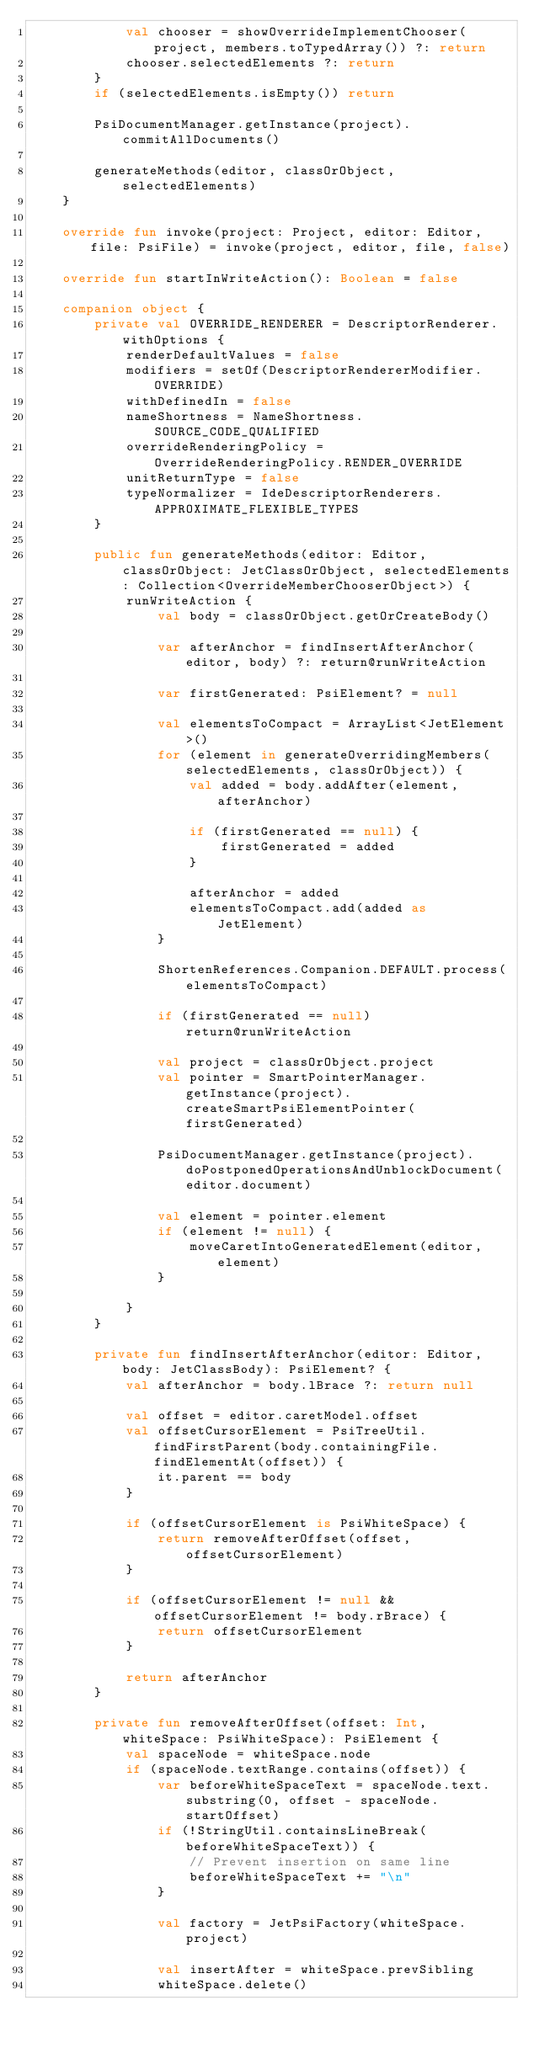<code> <loc_0><loc_0><loc_500><loc_500><_Kotlin_>            val chooser = showOverrideImplementChooser(project, members.toTypedArray()) ?: return
            chooser.selectedElements ?: return
        }
        if (selectedElements.isEmpty()) return

        PsiDocumentManager.getInstance(project).commitAllDocuments()

        generateMethods(editor, classOrObject, selectedElements)
    }

    override fun invoke(project: Project, editor: Editor, file: PsiFile) = invoke(project, editor, file, false)

    override fun startInWriteAction(): Boolean = false

    companion object {
        private val OVERRIDE_RENDERER = DescriptorRenderer.withOptions {
            renderDefaultValues = false
            modifiers = setOf(DescriptorRendererModifier.OVERRIDE)
            withDefinedIn = false
            nameShortness = NameShortness.SOURCE_CODE_QUALIFIED
            overrideRenderingPolicy = OverrideRenderingPolicy.RENDER_OVERRIDE
            unitReturnType = false
            typeNormalizer = IdeDescriptorRenderers.APPROXIMATE_FLEXIBLE_TYPES
        }

        public fun generateMethods(editor: Editor, classOrObject: JetClassOrObject, selectedElements: Collection<OverrideMemberChooserObject>) {
            runWriteAction {
                val body = classOrObject.getOrCreateBody()

                var afterAnchor = findInsertAfterAnchor(editor, body) ?: return@runWriteAction

                var firstGenerated: PsiElement? = null

                val elementsToCompact = ArrayList<JetElement>()
                for (element in generateOverridingMembers(selectedElements, classOrObject)) {
                    val added = body.addAfter(element, afterAnchor)

                    if (firstGenerated == null) {
                        firstGenerated = added
                    }

                    afterAnchor = added
                    elementsToCompact.add(added as JetElement)
                }

                ShortenReferences.Companion.DEFAULT.process(elementsToCompact)

                if (firstGenerated == null) return@runWriteAction

                val project = classOrObject.project
                val pointer = SmartPointerManager.getInstance(project).createSmartPsiElementPointer(firstGenerated)

                PsiDocumentManager.getInstance(project).doPostponedOperationsAndUnblockDocument(editor.document)

                val element = pointer.element
                if (element != null) {
                    moveCaretIntoGeneratedElement(editor, element)
                }

            }
        }

        private fun findInsertAfterAnchor(editor: Editor, body: JetClassBody): PsiElement? {
            val afterAnchor = body.lBrace ?: return null

            val offset = editor.caretModel.offset
            val offsetCursorElement = PsiTreeUtil.findFirstParent(body.containingFile.findElementAt(offset)) {
                it.parent == body
            }

            if (offsetCursorElement is PsiWhiteSpace) {
                return removeAfterOffset(offset, offsetCursorElement)
            }

            if (offsetCursorElement != null && offsetCursorElement != body.rBrace) {
                return offsetCursorElement
            }

            return afterAnchor
        }

        private fun removeAfterOffset(offset: Int, whiteSpace: PsiWhiteSpace): PsiElement {
            val spaceNode = whiteSpace.node
            if (spaceNode.textRange.contains(offset)) {
                var beforeWhiteSpaceText = spaceNode.text.substring(0, offset - spaceNode.startOffset)
                if (!StringUtil.containsLineBreak(beforeWhiteSpaceText)) {
                    // Prevent insertion on same line
                    beforeWhiteSpaceText += "\n"
                }

                val factory = JetPsiFactory(whiteSpace.project)

                val insertAfter = whiteSpace.prevSibling
                whiteSpace.delete()
</code> 